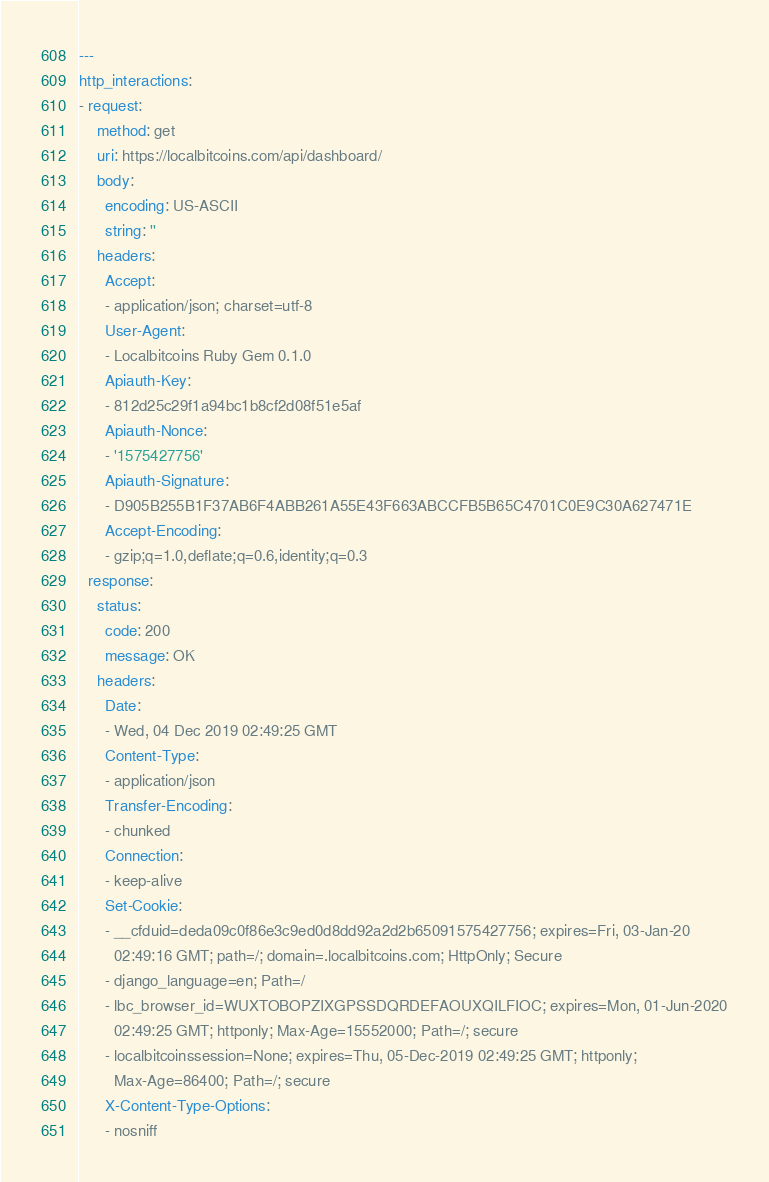<code> <loc_0><loc_0><loc_500><loc_500><_YAML_>---
http_interactions:
- request:
    method: get
    uri: https://localbitcoins.com/api/dashboard/
    body:
      encoding: US-ASCII
      string: ''
    headers:
      Accept:
      - application/json; charset=utf-8
      User-Agent:
      - Localbitcoins Ruby Gem 0.1.0
      Apiauth-Key:
      - 812d25c29f1a94bc1b8cf2d08f51e5af
      Apiauth-Nonce:
      - '1575427756'
      Apiauth-Signature:
      - D905B255B1F37AB6F4ABB261A55E43F663ABCCFB5B65C4701C0E9C30A627471E
      Accept-Encoding:
      - gzip;q=1.0,deflate;q=0.6,identity;q=0.3
  response:
    status:
      code: 200
      message: OK
    headers:
      Date:
      - Wed, 04 Dec 2019 02:49:25 GMT
      Content-Type:
      - application/json
      Transfer-Encoding:
      - chunked
      Connection:
      - keep-alive
      Set-Cookie:
      - __cfduid=deda09c0f86e3c9ed0d8dd92a2d2b65091575427756; expires=Fri, 03-Jan-20
        02:49:16 GMT; path=/; domain=.localbitcoins.com; HttpOnly; Secure
      - django_language=en; Path=/
      - lbc_browser_id=WUXTOBOPZIXGPSSDQRDEFAOUXQILFIOC; expires=Mon, 01-Jun-2020
        02:49:25 GMT; httponly; Max-Age=15552000; Path=/; secure
      - localbitcoinssession=None; expires=Thu, 05-Dec-2019 02:49:25 GMT; httponly;
        Max-Age=86400; Path=/; secure
      X-Content-Type-Options:
      - nosniff</code> 